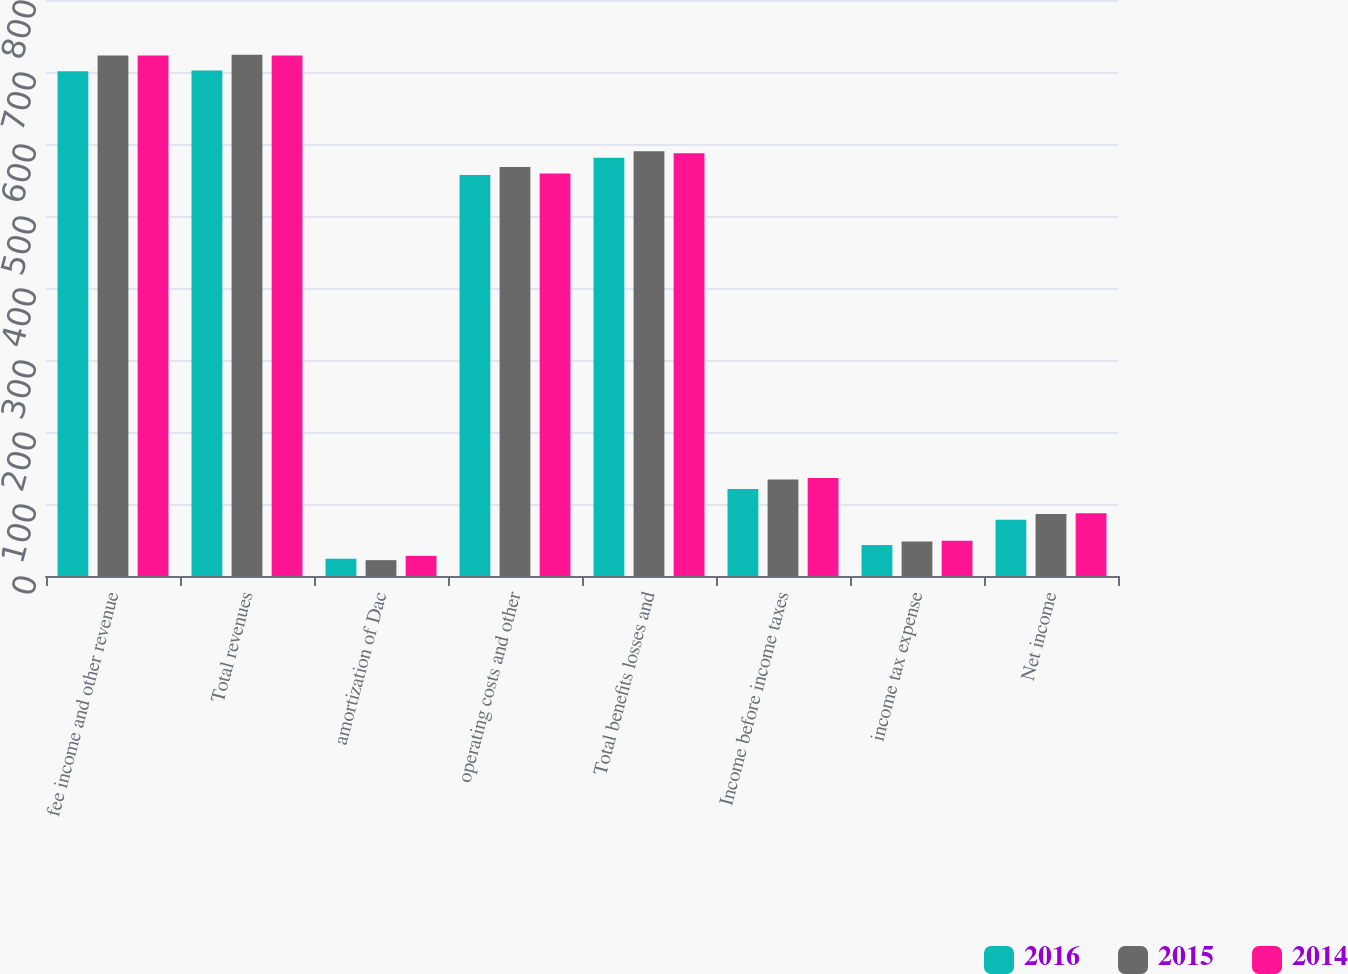Convert chart to OTSL. <chart><loc_0><loc_0><loc_500><loc_500><stacked_bar_chart><ecel><fcel>fee income and other revenue<fcel>Total revenues<fcel>amortization of Dac<fcel>operating costs and other<fcel>Total benefits losses and<fcel>Income before income taxes<fcel>income tax expense<fcel>Net income<nl><fcel>2016<fcel>701<fcel>702<fcel>24<fcel>557<fcel>581<fcel>121<fcel>43<fcel>78<nl><fcel>2015<fcel>723<fcel>724<fcel>22<fcel>568<fcel>590<fcel>134<fcel>48<fcel>86<nl><fcel>2014<fcel>723<fcel>723<fcel>28<fcel>559<fcel>587<fcel>136<fcel>49<fcel>87<nl></chart> 